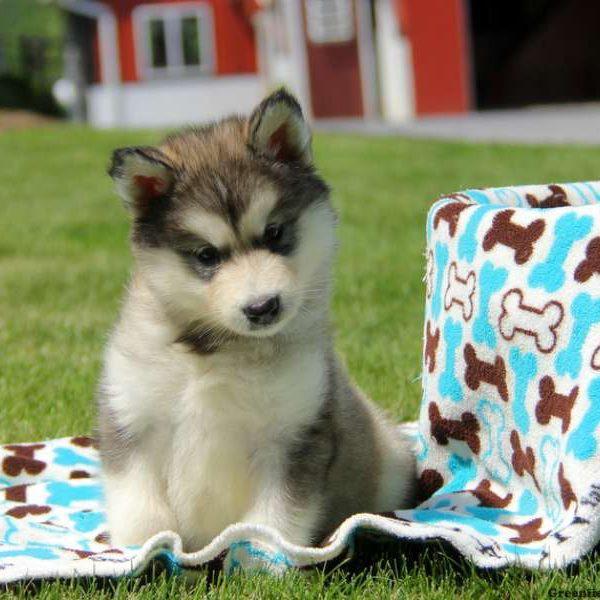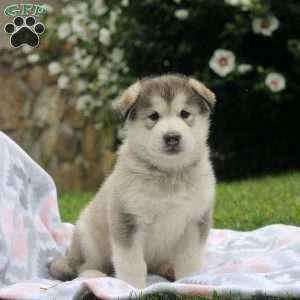The first image is the image on the left, the second image is the image on the right. Given the left and right images, does the statement "The left and right image contains a total of six dogs." hold true? Answer yes or no. No. The first image is the image on the left, the second image is the image on the right. For the images shown, is this caption "The left image contains five forward-facing husky puppies in two different coat color combinations." true? Answer yes or no. No. 